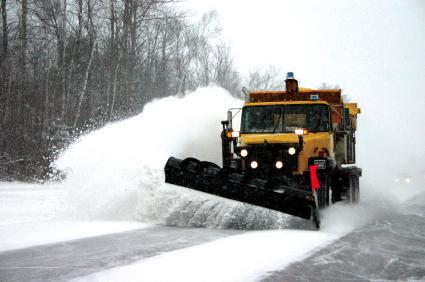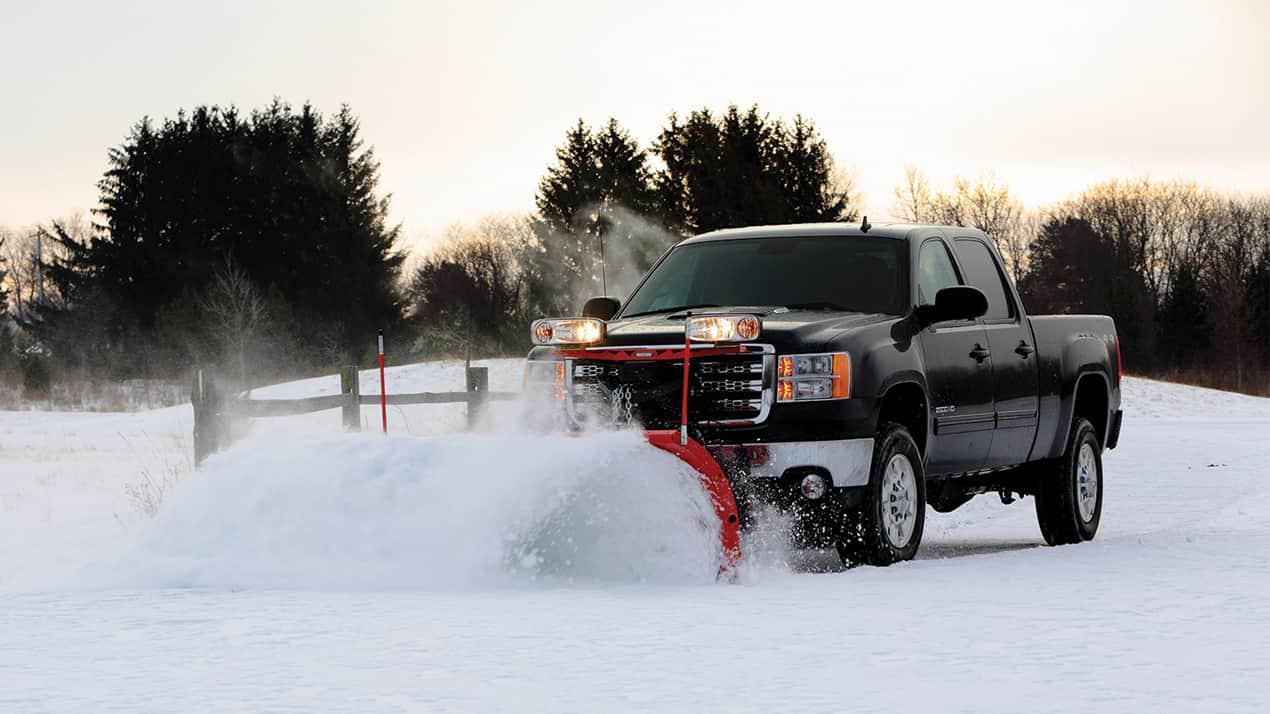The first image is the image on the left, the second image is the image on the right. Given the left and right images, does the statement "There is exactly one yellow truck on the image." hold true? Answer yes or no. Yes. 